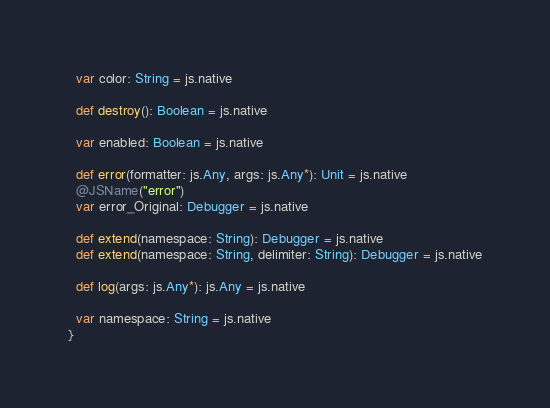Convert code to text. <code><loc_0><loc_0><loc_500><loc_500><_Scala_>  var color: String = js.native
  
  def destroy(): Boolean = js.native
  
  var enabled: Boolean = js.native
  
  def error(formatter: js.Any, args: js.Any*): Unit = js.native
  @JSName("error")
  var error_Original: Debugger = js.native
  
  def extend(namespace: String): Debugger = js.native
  def extend(namespace: String, delimiter: String): Debugger = js.native
  
  def log(args: js.Any*): js.Any = js.native
  
  var namespace: String = js.native
}
</code> 